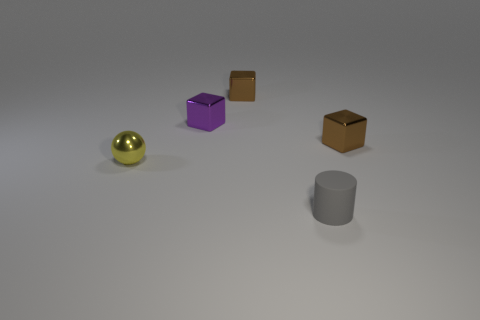Subtract all small brown blocks. How many blocks are left? 1 Add 2 yellow spheres. How many objects exist? 7 Subtract all spheres. How many objects are left? 4 Subtract all big blue metallic blocks. Subtract all metal blocks. How many objects are left? 2 Add 5 purple shiny blocks. How many purple shiny blocks are left? 6 Add 5 small things. How many small things exist? 10 Subtract 1 gray cylinders. How many objects are left? 4 